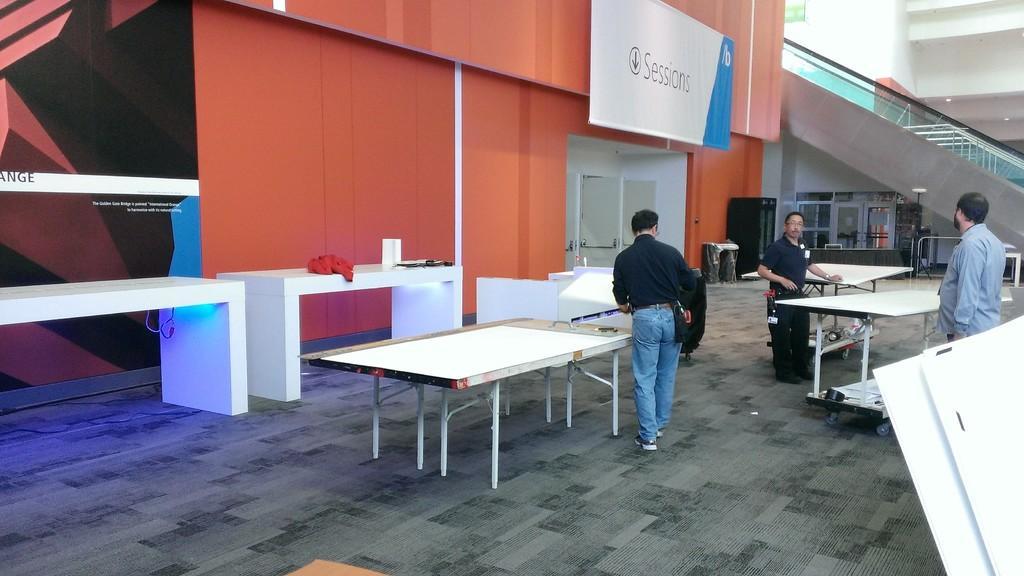How would you summarize this image in a sentence or two? This picture shows three Men and three table tennis tables. 